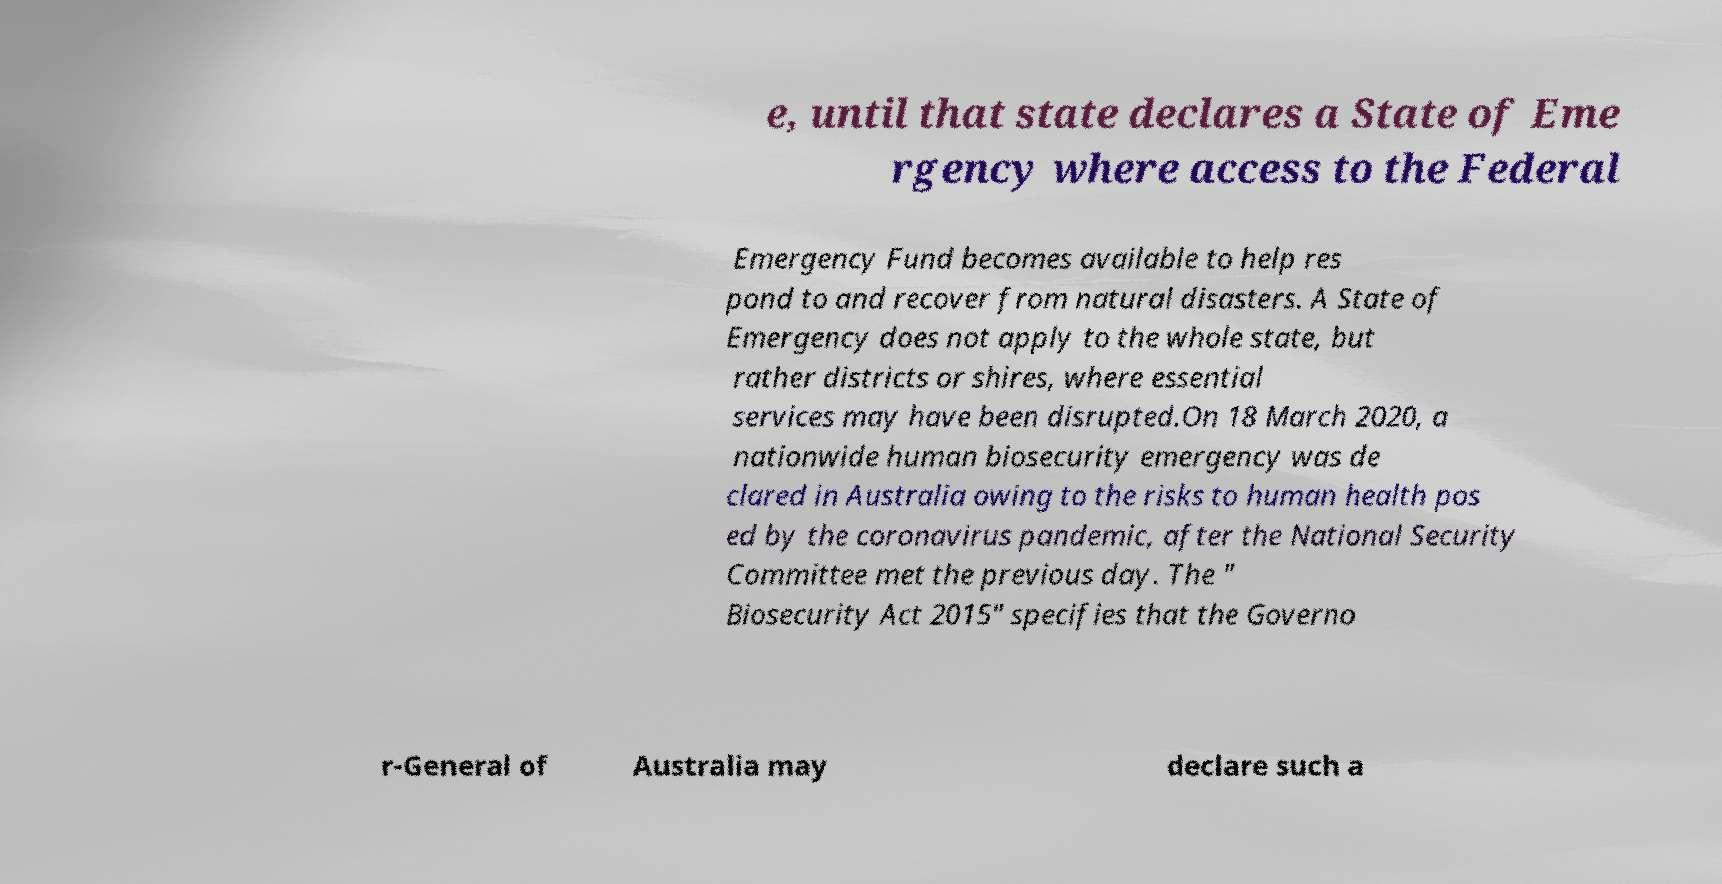There's text embedded in this image that I need extracted. Can you transcribe it verbatim? e, until that state declares a State of Eme rgency where access to the Federal Emergency Fund becomes available to help res pond to and recover from natural disasters. A State of Emergency does not apply to the whole state, but rather districts or shires, where essential services may have been disrupted.On 18 March 2020, a nationwide human biosecurity emergency was de clared in Australia owing to the risks to human health pos ed by the coronavirus pandemic, after the National Security Committee met the previous day. The " Biosecurity Act 2015" specifies that the Governo r-General of Australia may declare such a 